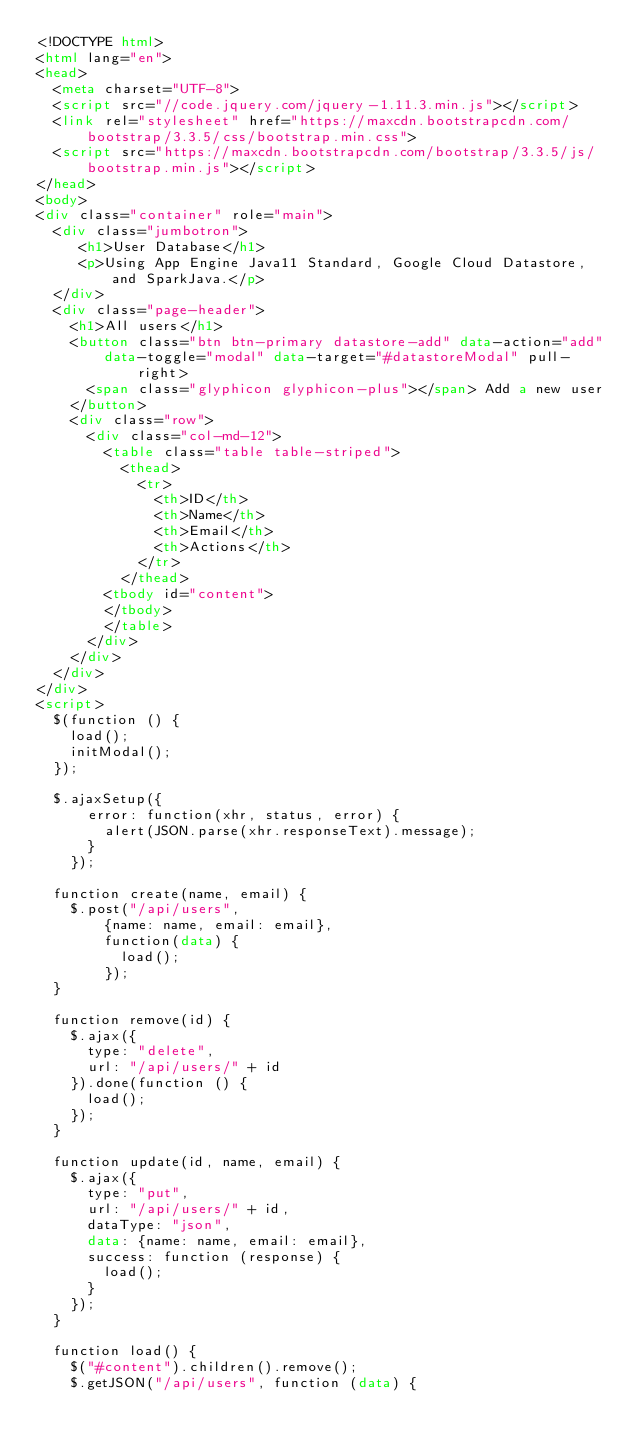<code> <loc_0><loc_0><loc_500><loc_500><_HTML_><!DOCTYPE html>
<html lang="en">
<head>
  <meta charset="UTF-8">
  <script src="//code.jquery.com/jquery-1.11.3.min.js"></script>
  <link rel="stylesheet" href="https://maxcdn.bootstrapcdn.com/bootstrap/3.3.5/css/bootstrap.min.css">
  <script src="https://maxcdn.bootstrapcdn.com/bootstrap/3.3.5/js/bootstrap.min.js"></script>
</head>
<body>
<div class="container" role="main">
  <div class="jumbotron">
     <h1>User Database</h1>
     <p>Using App Engine Java11 Standard, Google Cloud Datastore, and SparkJava.</p>
  </div>
  <div class="page-header">
    <h1>All users</h1>
    <button class="btn btn-primary datastore-add" data-action="add"
        data-toggle="modal" data-target="#datastoreModal" pull-right>
      <span class="glyphicon glyphicon-plus"></span> Add a new user
    </button>
    <div class="row">
      <div class="col-md-12">
        <table class="table table-striped">
          <thead>
            <tr>
              <th>ID</th>
              <th>Name</th>
              <th>Email</th>
              <th>Actions</th>
            </tr>
          </thead>
        <tbody id="content">
        </tbody>
        </table>
      </div>
    </div>
  </div>
</div>
<script>
  $(function () {
    load();
    initModal();
  });

  $.ajaxSetup({
      error: function(xhr, status, error) {
        alert(JSON.parse(xhr.responseText).message);
      }
    });

  function create(name, email) {
    $.post("/api/users",
        {name: name, email: email},
        function(data) {
          load();
        });
  }

  function remove(id) {
    $.ajax({
      type: "delete",
      url: "/api/users/" + id
    }).done(function () {
      load();
    });
  }

  function update(id, name, email) {
    $.ajax({
      type: "put",
      url: "/api/users/" + id,
      dataType: "json",
      data: {name: name, email: email},
      success: function (response) {
        load();
      }
    });
  }

  function load() {
    $("#content").children().remove();
    $.getJSON("/api/users", function (data) {</code> 